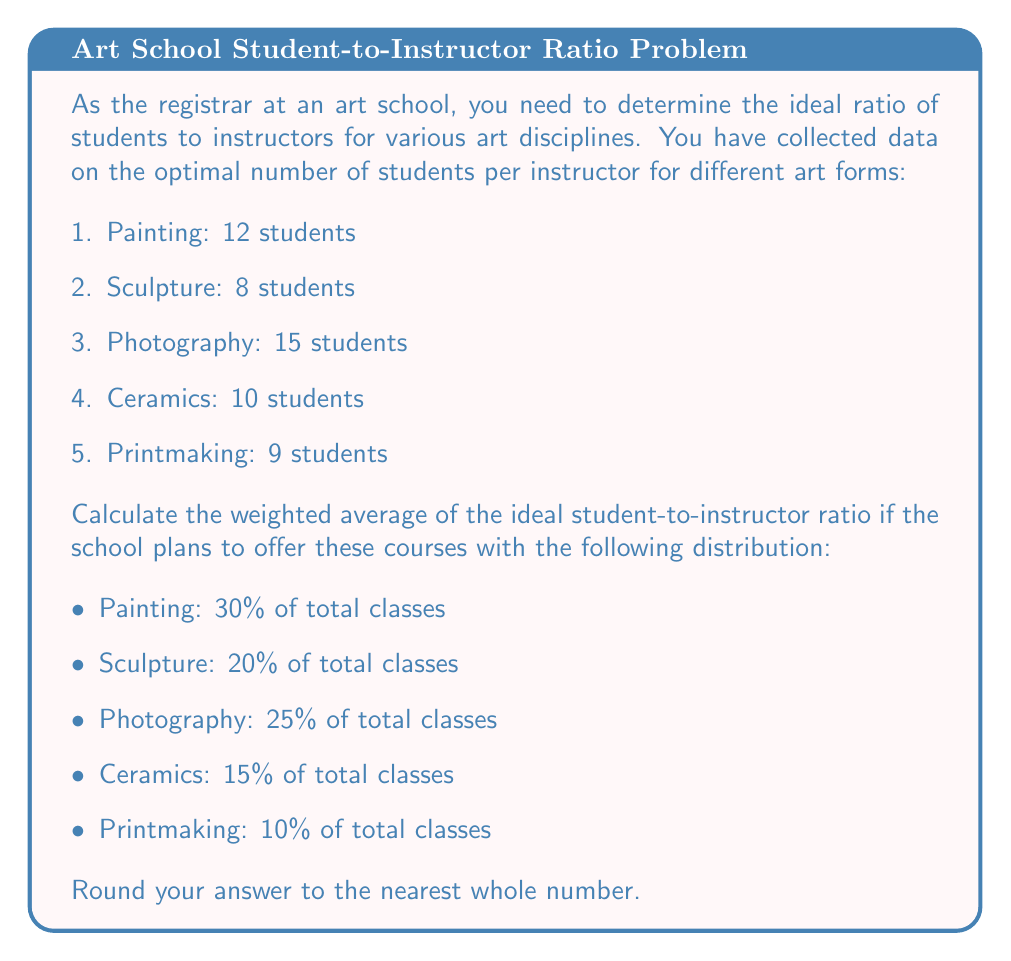Can you solve this math problem? To solve this problem, we'll follow these steps:

1. Identify the given data:
   - Painting: 12 students, 30% of classes
   - Sculpture: 8 students, 20% of classes
   - Photography: 15 students, 25% of classes
   - Ceramics: 10 students, 15% of classes
   - Printmaking: 9 students, 10% of classes

2. Calculate the weighted average using the formula:
   $$\text{Weighted Average} = \sum_{i=1}^{n} w_i x_i$$
   where $w_i$ is the weight (percentage) and $x_i$ is the value (number of students)

3. Multiply each discipline's student count by its corresponding weight:
   - Painting: $12 \times 0.30 = 3.60$
   - Sculpture: $8 \times 0.20 = 1.60$
   - Photography: $15 \times 0.25 = 3.75$
   - Ceramics: $10 \times 0.15 = 1.50$
   - Printmaking: $9 \times 0.10 = 0.90$

4. Sum up the weighted values:
   $$3.60 + 1.60 + 3.75 + 1.50 + 0.90 = 11.35$$

5. Round the result to the nearest whole number:
   $$11.35 \approx 11$$

Therefore, the weighted average of the ideal student-to-instructor ratio, rounded to the nearest whole number, is 11 students per instructor.
Answer: 11 students per instructor 